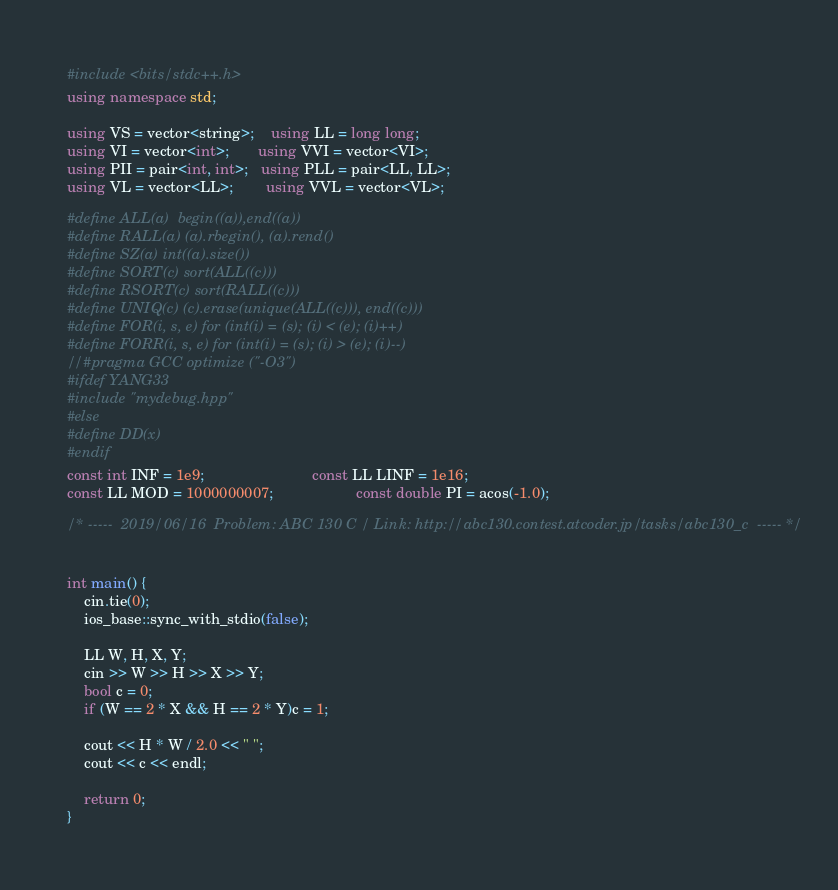Convert code to text. <code><loc_0><loc_0><loc_500><loc_500><_C++_>#include <bits/stdc++.h>
using namespace std;

using VS = vector<string>;    using LL = long long;
using VI = vector<int>;       using VVI = vector<VI>;
using PII = pair<int, int>;   using PLL = pair<LL, LL>;
using VL = vector<LL>;        using VVL = vector<VL>;

#define ALL(a)  begin((a)),end((a))
#define RALL(a) (a).rbegin(), (a).rend()
#define SZ(a) int((a).size())
#define SORT(c) sort(ALL((c)))
#define RSORT(c) sort(RALL((c)))
#define UNIQ(c) (c).erase(unique(ALL((c))), end((c)))
#define FOR(i, s, e) for (int(i) = (s); (i) < (e); (i)++)
#define FORR(i, s, e) for (int(i) = (s); (i) > (e); (i)--)
//#pragma GCC optimize ("-O3") 
#ifdef YANG33
#include "mydebug.hpp"
#else
#define DD(x) 
#endif
const int INF = 1e9;                          const LL LINF = 1e16;
const LL MOD = 1000000007;                    const double PI = acos(-1.0);

/* -----  2019/06/16  Problem: ABC 130 C / Link: http://abc130.contest.atcoder.jp/tasks/abc130_c  ----- */


int main() {
	cin.tie(0);
	ios_base::sync_with_stdio(false);

	LL W, H, X, Y;
	cin >> W >> H >> X >> Y;
	bool c = 0;
	if (W == 2 * X && H == 2 * Y)c = 1;

	cout << H * W / 2.0 << " ";
	cout << c << endl;

	return 0;
}
</code> 